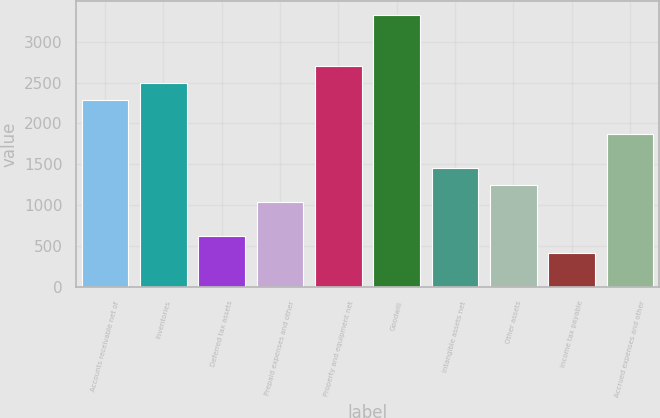<chart> <loc_0><loc_0><loc_500><loc_500><bar_chart><fcel>Accounts receivable net of<fcel>Inventories<fcel>Deferred tax assets<fcel>Prepaid expenses and other<fcel>Property and equipment net<fcel>Goodwill<fcel>Intangible assets net<fcel>Other assets<fcel>Income tax payable<fcel>Accrued expenses and other<nl><fcel>2287.19<fcel>2495.08<fcel>624.07<fcel>1039.85<fcel>2702.97<fcel>3326.64<fcel>1455.63<fcel>1247.74<fcel>416.18<fcel>1871.41<nl></chart> 